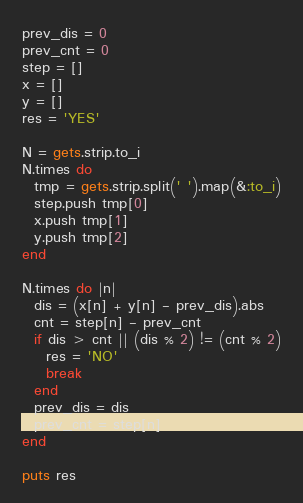<code> <loc_0><loc_0><loc_500><loc_500><_Ruby_>prev_dis = 0
prev_cnt = 0
step = []
x = []
y = []
res = 'YES'

N = gets.strip.to_i
N.times do
  tmp = gets.strip.split(' ').map(&:to_i)
  step.push tmp[0]
  x.push tmp[1]
  y.push tmp[2]
end

N.times do |n|
  dis = (x[n] + y[n] - prev_dis).abs
  cnt = step[n] - prev_cnt
  if dis > cnt || (dis % 2) != (cnt % 2)
    res = 'NO'
    break
  end
  prev_dis = dis
  prev_cnt = step[n]
end

puts res</code> 